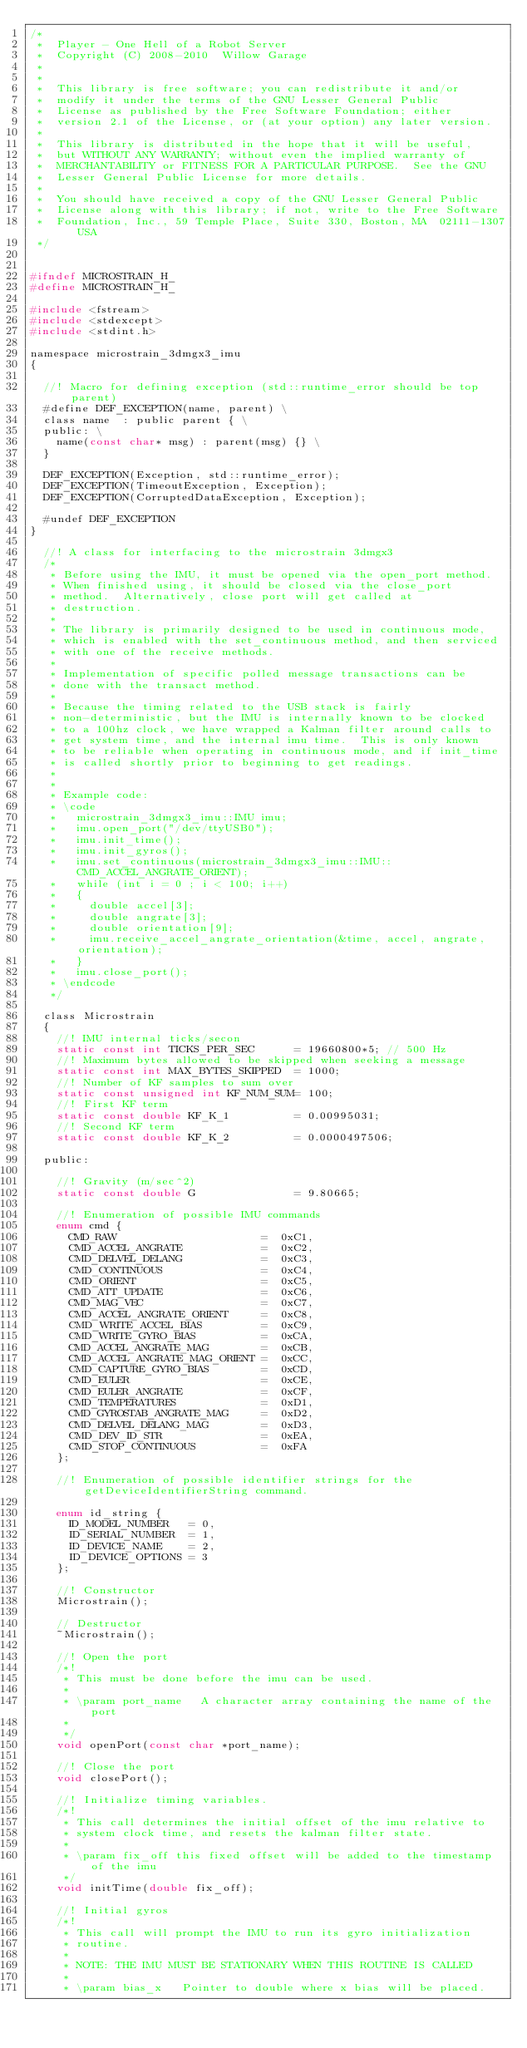Convert code to text. <code><loc_0><loc_0><loc_500><loc_500><_C_>/*
 *  Player - One Hell of a Robot Server
 *  Copyright (C) 2008-2010  Willow Garage
 *                      
 *
 *  This library is free software; you can redistribute it and/or
 *  modify it under the terms of the GNU Lesser General Public
 *  License as published by the Free Software Foundation; either
 *  version 2.1 of the License, or (at your option) any later version.
 *
 *  This library is distributed in the hope that it will be useful,
 *  but WITHOUT ANY WARRANTY; without even the implied warranty of
 *  MERCHANTABILITY or FITNESS FOR A PARTICULAR PURPOSE.  See the GNU
 *  Lesser General Public License for more details.
 *
 *  You should have received a copy of the GNU Lesser General Public
 *  License along with this library; if not, write to the Free Software
 *  Foundation, Inc., 59 Temple Place, Suite 330, Boston, MA  02111-1307  USA
 */


#ifndef MICROSTRAIN_H_
#define MICROSTRAIN_H_

#include <fstream>
#include <stdexcept>
#include <stdint.h>

namespace microstrain_3dmgx3_imu
{

  //! Macro for defining exception (std::runtime_error should be top parent)
  #define DEF_EXCEPTION(name, parent) \
  class name  : public parent { \
  public: \
    name(const char* msg) : parent(msg) {} \
  }

  DEF_EXCEPTION(Exception, std::runtime_error);
  DEF_EXCEPTION(TimeoutException, Exception);
  DEF_EXCEPTION(CorruptedDataException, Exception);

  #undef DEF_EXCEPTION
}

  //! A class for interfacing to the microstrain 3dmgx3
  /*
   * Before using the IMU, it must be opened via the open_port method.
   * When finished using, it should be closed via the close_port
   * method.  Alternatively, close port will get called at
   * destruction.
   *
   * The library is primarily designed to be used in continuous mode,
   * which is enabled with the set_continuous method, and then serviced
   * with one of the receive methods.
   *
   * Implementation of specific polled message transactions can be
   * done with the transact method.
   *
   * Because the timing related to the USB stack is fairly
   * non-deterministic, but the IMU is internally known to be clocked
   * to a 100hz clock, we have wrapped a Kalman filter around calls to
   * get system time, and the internal imu time.  This is only known
   * to be reliable when operating in continuous mode, and if init_time
   * is called shortly prior to beginning to get readings.
   * 
   *
   * Example code:
   * \code
   *   microstrain_3dmgx3_imu::IMU imu;
   *   imu.open_port("/dev/ttyUSB0");
   *   imu.init_time();
   *   imu.init_gyros();
   *   imu.set_continuous(microstrain_3dmgx3_imu::IMU::CMD_ACCEL_ANGRATE_ORIENT);
   *   while (int i = 0 ; i < 100; i++)
   *   {
   *     double accel[3];
   *     double angrate[3];
   *     double orientation[9];
   *     imu.receive_accel_angrate_orientation(&time, accel, angrate, orientation);
   *   }
   *   imu.close_port();
   * \endcode
   */

  class Microstrain
  {
    //! IMU internal ticks/secon
    static const int TICKS_PER_SEC      = 19660800*5; // 500 Hz
    //! Maximum bytes allowed to be skipped when seeking a message
    static const int MAX_BYTES_SKIPPED  = 1000;
    //! Number of KF samples to sum over
    static const unsigned int KF_NUM_SUM= 100;
    //! First KF term
    static const double KF_K_1          = 0.00995031;
    //! Second KF term
    static const double KF_K_2          = 0.0000497506;

  public: 

    //! Gravity (m/sec^2)
    static const double G               = 9.80665;    

    //! Enumeration of possible IMU commands
    enum cmd {
      CMD_RAW                      =  0xC1,
      CMD_ACCEL_ANGRATE            =  0xC2,
      CMD_DELVEL_DELANG            =  0xC3,
      CMD_CONTINUOUS               =  0xC4,
      CMD_ORIENT                   =  0xC5,
      CMD_ATT_UPDATE               =  0xC6,
      CMD_MAG_VEC                  =  0xC7,
      CMD_ACCEL_ANGRATE_ORIENT     =  0xC8,
      CMD_WRITE_ACCEL_BIAS         =  0xC9,
      CMD_WRITE_GYRO_BIAS          =  0xCA,
      CMD_ACCEL_ANGRATE_MAG        =  0xCB,
      CMD_ACCEL_ANGRATE_MAG_ORIENT =  0xCC,
      CMD_CAPTURE_GYRO_BIAS        =  0xCD,
      CMD_EULER                    =  0xCE,
      CMD_EULER_ANGRATE            =  0xCF,
      CMD_TEMPERATURES             =  0xD1,
      CMD_GYROSTAB_ANGRATE_MAG     =  0xD2,
      CMD_DELVEL_DELANG_MAG        =  0xD3,
      CMD_DEV_ID_STR               =  0xEA,
      CMD_STOP_CONTINUOUS          =  0xFA
    };

    //! Enumeration of possible identifier strings for the getDeviceIdentifierString command.

    enum id_string {
      ID_MODEL_NUMBER   = 0,
      ID_SERIAL_NUMBER  = 1,
      ID_DEVICE_NAME    = 2,
      ID_DEVICE_OPTIONS = 3
    };

    //! Constructor
    Microstrain();

    // Destructor
    ~Microstrain();

    //! Open the port
    /*! 
     * This must be done before the imu can be used.
     * 
     * \param port_name   A character array containing the name of the port
     *
     */
    void openPort(const char *port_name);

    //! Close the port
    void closePort();

    //! Initialize timing variables.
    /*!
     * This call determines the initial offset of the imu relative to 
     * system clock time, and resets the kalman filter state.
     *
     * \param fix_off this fixed offset will be added to the timestamp of the imu
     */
    void initTime(double fix_off);

    //! Initial gyros
    /*! 
     * This call will prompt the IMU to run its gyro initialization
     * routine.  
     *
     * NOTE: THE IMU MUST BE STATIONARY WHEN THIS ROUTINE IS CALLED
     *
     * \param bias_x   Pointer to double where x bias will be placed.</code> 